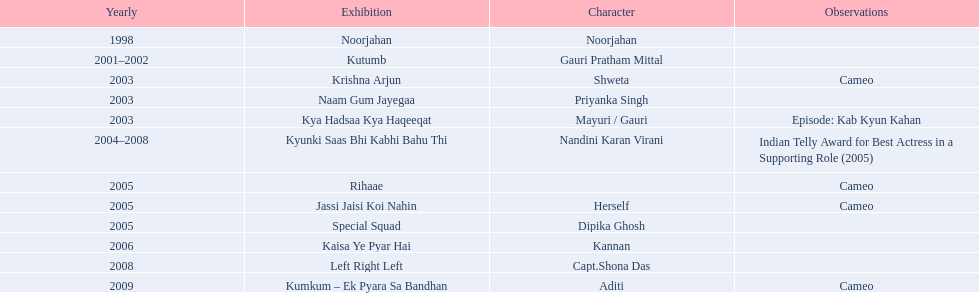What role  was played for the latest show Cameo. Who played the last cameo before ? Jassi Jaisi Koi Nahin. 